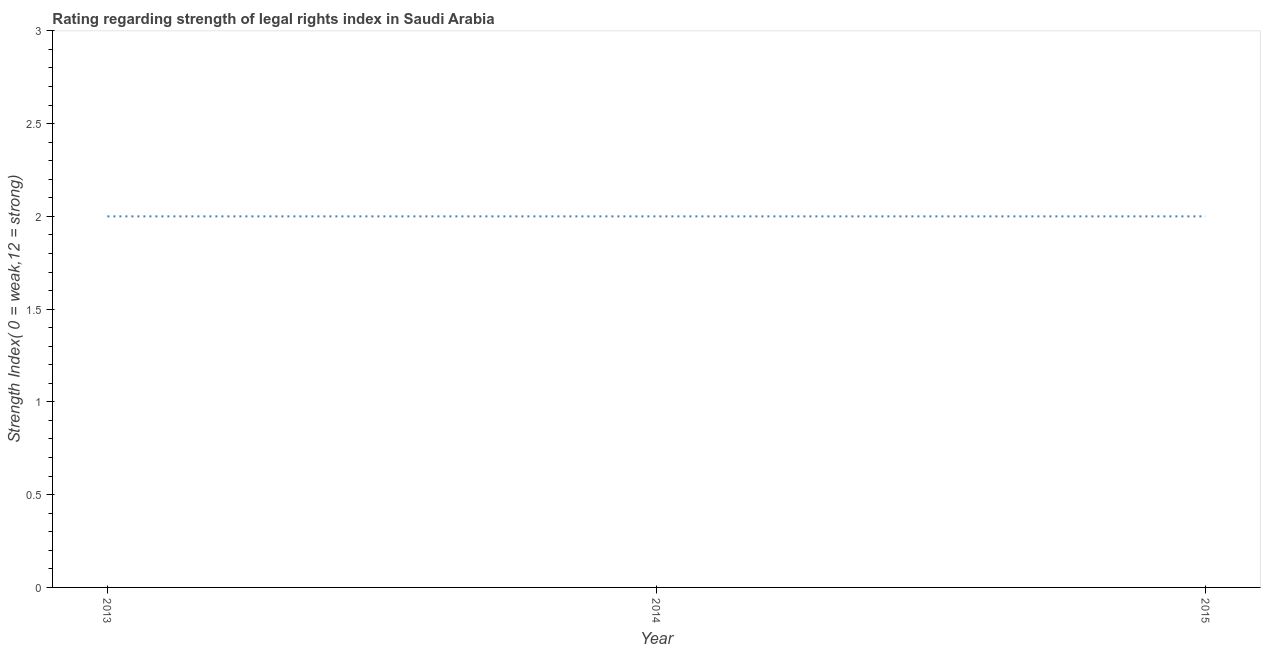What is the strength of legal rights index in 2013?
Your answer should be compact. 2. Across all years, what is the maximum strength of legal rights index?
Give a very brief answer. 2. Across all years, what is the minimum strength of legal rights index?
Keep it short and to the point. 2. What is the sum of the strength of legal rights index?
Offer a terse response. 6. What is the average strength of legal rights index per year?
Offer a very short reply. 2. What is the median strength of legal rights index?
Make the answer very short. 2. In how many years, is the strength of legal rights index greater than 2.1 ?
Provide a succinct answer. 0. Is the difference between the strength of legal rights index in 2014 and 2015 greater than the difference between any two years?
Make the answer very short. Yes. What is the difference between the highest and the second highest strength of legal rights index?
Ensure brevity in your answer.  0. Is the sum of the strength of legal rights index in 2013 and 2014 greater than the maximum strength of legal rights index across all years?
Give a very brief answer. Yes. What is the difference between the highest and the lowest strength of legal rights index?
Offer a terse response. 0. How many lines are there?
Keep it short and to the point. 1. What is the difference between two consecutive major ticks on the Y-axis?
Your answer should be very brief. 0.5. Are the values on the major ticks of Y-axis written in scientific E-notation?
Ensure brevity in your answer.  No. Does the graph contain any zero values?
Your response must be concise. No. Does the graph contain grids?
Keep it short and to the point. No. What is the title of the graph?
Keep it short and to the point. Rating regarding strength of legal rights index in Saudi Arabia. What is the label or title of the Y-axis?
Your response must be concise. Strength Index( 0 = weak,12 = strong). What is the Strength Index( 0 = weak,12 = strong) of 2014?
Your answer should be very brief. 2. What is the Strength Index( 0 = weak,12 = strong) in 2015?
Give a very brief answer. 2. What is the difference between the Strength Index( 0 = weak,12 = strong) in 2013 and 2014?
Your response must be concise. 0. What is the ratio of the Strength Index( 0 = weak,12 = strong) in 2013 to that in 2014?
Offer a very short reply. 1. What is the ratio of the Strength Index( 0 = weak,12 = strong) in 2014 to that in 2015?
Your answer should be very brief. 1. 